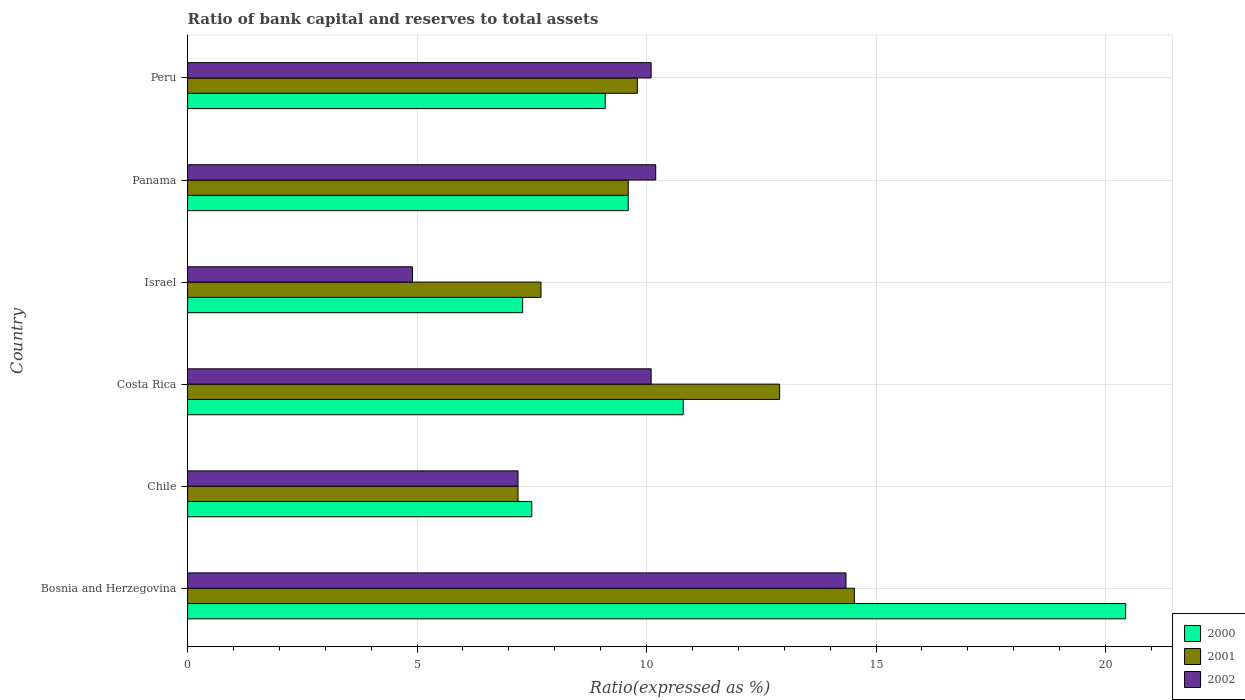How many different coloured bars are there?
Ensure brevity in your answer.  3. Are the number of bars per tick equal to the number of legend labels?
Make the answer very short. Yes. How many bars are there on the 6th tick from the top?
Offer a terse response. 3. What is the label of the 4th group of bars from the top?
Offer a terse response. Costa Rica. In how many cases, is the number of bars for a given country not equal to the number of legend labels?
Keep it short and to the point. 0. What is the ratio of bank capital and reserves to total assets in 2000 in Costa Rica?
Your response must be concise. 10.8. Across all countries, what is the maximum ratio of bank capital and reserves to total assets in 2001?
Offer a terse response. 14.53. Across all countries, what is the minimum ratio of bank capital and reserves to total assets in 2001?
Provide a succinct answer. 7.2. In which country was the ratio of bank capital and reserves to total assets in 2001 maximum?
Offer a very short reply. Bosnia and Herzegovina. What is the total ratio of bank capital and reserves to total assets in 2001 in the graph?
Your answer should be compact. 61.73. What is the difference between the ratio of bank capital and reserves to total assets in 2001 in Panama and that in Peru?
Provide a short and direct response. -0.2. What is the difference between the ratio of bank capital and reserves to total assets in 2001 in Panama and the ratio of bank capital and reserves to total assets in 2000 in Costa Rica?
Your answer should be compact. -1.2. What is the average ratio of bank capital and reserves to total assets in 2000 per country?
Give a very brief answer. 10.79. What is the difference between the ratio of bank capital and reserves to total assets in 2000 and ratio of bank capital and reserves to total assets in 2002 in Costa Rica?
Keep it short and to the point. 0.7. What is the ratio of the ratio of bank capital and reserves to total assets in 2000 in Israel to that in Panama?
Your response must be concise. 0.76. Is the difference between the ratio of bank capital and reserves to total assets in 2000 in Israel and Panama greater than the difference between the ratio of bank capital and reserves to total assets in 2002 in Israel and Panama?
Give a very brief answer. Yes. What is the difference between the highest and the second highest ratio of bank capital and reserves to total assets in 2001?
Your response must be concise. 1.63. What is the difference between the highest and the lowest ratio of bank capital and reserves to total assets in 2001?
Provide a succinct answer. 7.33. In how many countries, is the ratio of bank capital and reserves to total assets in 2001 greater than the average ratio of bank capital and reserves to total assets in 2001 taken over all countries?
Offer a terse response. 2. What does the 2nd bar from the top in Israel represents?
Offer a very short reply. 2001. How many countries are there in the graph?
Your response must be concise. 6. Are the values on the major ticks of X-axis written in scientific E-notation?
Your response must be concise. No. Does the graph contain any zero values?
Your answer should be compact. No. Does the graph contain grids?
Offer a very short reply. Yes. How many legend labels are there?
Provide a short and direct response. 3. How are the legend labels stacked?
Offer a very short reply. Vertical. What is the title of the graph?
Ensure brevity in your answer.  Ratio of bank capital and reserves to total assets. Does "1988" appear as one of the legend labels in the graph?
Make the answer very short. No. What is the label or title of the X-axis?
Your answer should be compact. Ratio(expressed as %). What is the Ratio(expressed as %) in 2000 in Bosnia and Herzegovina?
Offer a terse response. 20.44. What is the Ratio(expressed as %) in 2001 in Bosnia and Herzegovina?
Provide a succinct answer. 14.53. What is the Ratio(expressed as %) of 2002 in Bosnia and Herzegovina?
Offer a very short reply. 14.35. What is the Ratio(expressed as %) in 2001 in Costa Rica?
Your response must be concise. 12.9. What is the Ratio(expressed as %) of 2002 in Costa Rica?
Offer a terse response. 10.1. What is the Ratio(expressed as %) of 2002 in Panama?
Ensure brevity in your answer.  10.2. What is the Ratio(expressed as %) in 2001 in Peru?
Make the answer very short. 9.8. What is the Ratio(expressed as %) in 2002 in Peru?
Offer a very short reply. 10.1. Across all countries, what is the maximum Ratio(expressed as %) in 2000?
Give a very brief answer. 20.44. Across all countries, what is the maximum Ratio(expressed as %) of 2001?
Your answer should be compact. 14.53. Across all countries, what is the maximum Ratio(expressed as %) of 2002?
Provide a short and direct response. 14.35. Across all countries, what is the minimum Ratio(expressed as %) in 2002?
Offer a terse response. 4.9. What is the total Ratio(expressed as %) in 2000 in the graph?
Your answer should be very brief. 64.74. What is the total Ratio(expressed as %) in 2001 in the graph?
Your answer should be very brief. 61.73. What is the total Ratio(expressed as %) in 2002 in the graph?
Your answer should be compact. 56.85. What is the difference between the Ratio(expressed as %) of 2000 in Bosnia and Herzegovina and that in Chile?
Your answer should be very brief. 12.94. What is the difference between the Ratio(expressed as %) in 2001 in Bosnia and Herzegovina and that in Chile?
Ensure brevity in your answer.  7.33. What is the difference between the Ratio(expressed as %) of 2002 in Bosnia and Herzegovina and that in Chile?
Ensure brevity in your answer.  7.15. What is the difference between the Ratio(expressed as %) of 2000 in Bosnia and Herzegovina and that in Costa Rica?
Offer a terse response. 9.64. What is the difference between the Ratio(expressed as %) in 2001 in Bosnia and Herzegovina and that in Costa Rica?
Provide a short and direct response. 1.63. What is the difference between the Ratio(expressed as %) in 2002 in Bosnia and Herzegovina and that in Costa Rica?
Provide a short and direct response. 4.25. What is the difference between the Ratio(expressed as %) in 2000 in Bosnia and Herzegovina and that in Israel?
Keep it short and to the point. 13.14. What is the difference between the Ratio(expressed as %) in 2001 in Bosnia and Herzegovina and that in Israel?
Offer a terse response. 6.83. What is the difference between the Ratio(expressed as %) of 2002 in Bosnia and Herzegovina and that in Israel?
Offer a terse response. 9.45. What is the difference between the Ratio(expressed as %) in 2000 in Bosnia and Herzegovina and that in Panama?
Offer a terse response. 10.84. What is the difference between the Ratio(expressed as %) of 2001 in Bosnia and Herzegovina and that in Panama?
Offer a terse response. 4.93. What is the difference between the Ratio(expressed as %) of 2002 in Bosnia and Herzegovina and that in Panama?
Provide a short and direct response. 4.15. What is the difference between the Ratio(expressed as %) of 2000 in Bosnia and Herzegovina and that in Peru?
Your answer should be very brief. 11.34. What is the difference between the Ratio(expressed as %) in 2001 in Bosnia and Herzegovina and that in Peru?
Offer a terse response. 4.73. What is the difference between the Ratio(expressed as %) of 2002 in Bosnia and Herzegovina and that in Peru?
Keep it short and to the point. 4.25. What is the difference between the Ratio(expressed as %) of 2002 in Chile and that in Costa Rica?
Keep it short and to the point. -2.9. What is the difference between the Ratio(expressed as %) of 2000 in Chile and that in Israel?
Give a very brief answer. 0.2. What is the difference between the Ratio(expressed as %) in 2001 in Chile and that in Israel?
Ensure brevity in your answer.  -0.5. What is the difference between the Ratio(expressed as %) of 2002 in Chile and that in Israel?
Your response must be concise. 2.3. What is the difference between the Ratio(expressed as %) in 2000 in Chile and that in Panama?
Your answer should be very brief. -2.1. What is the difference between the Ratio(expressed as %) in 2001 in Chile and that in Panama?
Ensure brevity in your answer.  -2.4. What is the difference between the Ratio(expressed as %) of 2002 in Chile and that in Panama?
Ensure brevity in your answer.  -3. What is the difference between the Ratio(expressed as %) of 2000 in Chile and that in Peru?
Provide a short and direct response. -1.6. What is the difference between the Ratio(expressed as %) in 2001 in Chile and that in Peru?
Keep it short and to the point. -2.6. What is the difference between the Ratio(expressed as %) of 2002 in Costa Rica and that in Israel?
Provide a short and direct response. 5.2. What is the difference between the Ratio(expressed as %) in 2000 in Costa Rica and that in Panama?
Your answer should be very brief. 1.2. What is the difference between the Ratio(expressed as %) of 2001 in Costa Rica and that in Panama?
Provide a succinct answer. 3.3. What is the difference between the Ratio(expressed as %) in 2000 in Costa Rica and that in Peru?
Ensure brevity in your answer.  1.7. What is the difference between the Ratio(expressed as %) of 2002 in Costa Rica and that in Peru?
Provide a succinct answer. 0. What is the difference between the Ratio(expressed as %) in 2000 in Israel and that in Panama?
Give a very brief answer. -2.3. What is the difference between the Ratio(expressed as %) of 2001 in Israel and that in Peru?
Provide a short and direct response. -2.1. What is the difference between the Ratio(expressed as %) in 2002 in Panama and that in Peru?
Keep it short and to the point. 0.1. What is the difference between the Ratio(expressed as %) in 2000 in Bosnia and Herzegovina and the Ratio(expressed as %) in 2001 in Chile?
Make the answer very short. 13.24. What is the difference between the Ratio(expressed as %) in 2000 in Bosnia and Herzegovina and the Ratio(expressed as %) in 2002 in Chile?
Your answer should be compact. 13.24. What is the difference between the Ratio(expressed as %) of 2001 in Bosnia and Herzegovina and the Ratio(expressed as %) of 2002 in Chile?
Your answer should be compact. 7.33. What is the difference between the Ratio(expressed as %) of 2000 in Bosnia and Herzegovina and the Ratio(expressed as %) of 2001 in Costa Rica?
Give a very brief answer. 7.54. What is the difference between the Ratio(expressed as %) in 2000 in Bosnia and Herzegovina and the Ratio(expressed as %) in 2002 in Costa Rica?
Offer a very short reply. 10.34. What is the difference between the Ratio(expressed as %) in 2001 in Bosnia and Herzegovina and the Ratio(expressed as %) in 2002 in Costa Rica?
Your answer should be very brief. 4.43. What is the difference between the Ratio(expressed as %) in 2000 in Bosnia and Herzegovina and the Ratio(expressed as %) in 2001 in Israel?
Your answer should be compact. 12.74. What is the difference between the Ratio(expressed as %) in 2000 in Bosnia and Herzegovina and the Ratio(expressed as %) in 2002 in Israel?
Ensure brevity in your answer.  15.54. What is the difference between the Ratio(expressed as %) in 2001 in Bosnia and Herzegovina and the Ratio(expressed as %) in 2002 in Israel?
Provide a short and direct response. 9.63. What is the difference between the Ratio(expressed as %) of 2000 in Bosnia and Herzegovina and the Ratio(expressed as %) of 2001 in Panama?
Your response must be concise. 10.84. What is the difference between the Ratio(expressed as %) of 2000 in Bosnia and Herzegovina and the Ratio(expressed as %) of 2002 in Panama?
Your answer should be very brief. 10.24. What is the difference between the Ratio(expressed as %) of 2001 in Bosnia and Herzegovina and the Ratio(expressed as %) of 2002 in Panama?
Offer a terse response. 4.33. What is the difference between the Ratio(expressed as %) of 2000 in Bosnia and Herzegovina and the Ratio(expressed as %) of 2001 in Peru?
Make the answer very short. 10.64. What is the difference between the Ratio(expressed as %) of 2000 in Bosnia and Herzegovina and the Ratio(expressed as %) of 2002 in Peru?
Provide a succinct answer. 10.34. What is the difference between the Ratio(expressed as %) in 2001 in Bosnia and Herzegovina and the Ratio(expressed as %) in 2002 in Peru?
Provide a short and direct response. 4.43. What is the difference between the Ratio(expressed as %) in 2000 in Chile and the Ratio(expressed as %) in 2001 in Costa Rica?
Your response must be concise. -5.4. What is the difference between the Ratio(expressed as %) in 2000 in Chile and the Ratio(expressed as %) in 2002 in Costa Rica?
Your response must be concise. -2.6. What is the difference between the Ratio(expressed as %) of 2001 in Chile and the Ratio(expressed as %) of 2002 in Costa Rica?
Offer a terse response. -2.9. What is the difference between the Ratio(expressed as %) of 2000 in Chile and the Ratio(expressed as %) of 2002 in Israel?
Your response must be concise. 2.6. What is the difference between the Ratio(expressed as %) of 2001 in Chile and the Ratio(expressed as %) of 2002 in Israel?
Ensure brevity in your answer.  2.3. What is the difference between the Ratio(expressed as %) of 2000 in Chile and the Ratio(expressed as %) of 2002 in Panama?
Your answer should be very brief. -2.7. What is the difference between the Ratio(expressed as %) of 2000 in Chile and the Ratio(expressed as %) of 2002 in Peru?
Your answer should be very brief. -2.6. What is the difference between the Ratio(expressed as %) of 2001 in Chile and the Ratio(expressed as %) of 2002 in Peru?
Provide a succinct answer. -2.9. What is the difference between the Ratio(expressed as %) of 2000 in Costa Rica and the Ratio(expressed as %) of 2001 in Israel?
Your response must be concise. 3.1. What is the difference between the Ratio(expressed as %) of 2001 in Costa Rica and the Ratio(expressed as %) of 2002 in Israel?
Give a very brief answer. 8. What is the difference between the Ratio(expressed as %) of 2000 in Costa Rica and the Ratio(expressed as %) of 2001 in Panama?
Provide a succinct answer. 1.2. What is the difference between the Ratio(expressed as %) in 2001 in Costa Rica and the Ratio(expressed as %) in 2002 in Panama?
Make the answer very short. 2.7. What is the difference between the Ratio(expressed as %) in 2000 in Israel and the Ratio(expressed as %) in 2002 in Panama?
Your answer should be very brief. -2.9. What is the difference between the Ratio(expressed as %) in 2000 in Israel and the Ratio(expressed as %) in 2002 in Peru?
Your answer should be very brief. -2.8. What is the average Ratio(expressed as %) in 2000 per country?
Provide a short and direct response. 10.79. What is the average Ratio(expressed as %) of 2001 per country?
Keep it short and to the point. 10.29. What is the average Ratio(expressed as %) of 2002 per country?
Ensure brevity in your answer.  9.47. What is the difference between the Ratio(expressed as %) in 2000 and Ratio(expressed as %) in 2001 in Bosnia and Herzegovina?
Your answer should be very brief. 5.91. What is the difference between the Ratio(expressed as %) in 2000 and Ratio(expressed as %) in 2002 in Bosnia and Herzegovina?
Your answer should be compact. 6.09. What is the difference between the Ratio(expressed as %) in 2001 and Ratio(expressed as %) in 2002 in Bosnia and Herzegovina?
Provide a succinct answer. 0.18. What is the difference between the Ratio(expressed as %) of 2001 and Ratio(expressed as %) of 2002 in Chile?
Keep it short and to the point. 0. What is the difference between the Ratio(expressed as %) of 2000 and Ratio(expressed as %) of 2001 in Costa Rica?
Keep it short and to the point. -2.1. What is the difference between the Ratio(expressed as %) of 2000 and Ratio(expressed as %) of 2001 in Israel?
Give a very brief answer. -0.4. What is the difference between the Ratio(expressed as %) of 2000 and Ratio(expressed as %) of 2002 in Israel?
Give a very brief answer. 2.4. What is the difference between the Ratio(expressed as %) in 2001 and Ratio(expressed as %) in 2002 in Israel?
Your answer should be compact. 2.8. What is the difference between the Ratio(expressed as %) of 2000 and Ratio(expressed as %) of 2002 in Peru?
Your answer should be very brief. -1. What is the difference between the Ratio(expressed as %) in 2001 and Ratio(expressed as %) in 2002 in Peru?
Offer a very short reply. -0.3. What is the ratio of the Ratio(expressed as %) in 2000 in Bosnia and Herzegovina to that in Chile?
Keep it short and to the point. 2.73. What is the ratio of the Ratio(expressed as %) of 2001 in Bosnia and Herzegovina to that in Chile?
Give a very brief answer. 2.02. What is the ratio of the Ratio(expressed as %) of 2002 in Bosnia and Herzegovina to that in Chile?
Provide a short and direct response. 1.99. What is the ratio of the Ratio(expressed as %) in 2000 in Bosnia and Herzegovina to that in Costa Rica?
Offer a very short reply. 1.89. What is the ratio of the Ratio(expressed as %) in 2001 in Bosnia and Herzegovina to that in Costa Rica?
Offer a very short reply. 1.13. What is the ratio of the Ratio(expressed as %) of 2002 in Bosnia and Herzegovina to that in Costa Rica?
Offer a very short reply. 1.42. What is the ratio of the Ratio(expressed as %) of 2000 in Bosnia and Herzegovina to that in Israel?
Your response must be concise. 2.8. What is the ratio of the Ratio(expressed as %) in 2001 in Bosnia and Herzegovina to that in Israel?
Keep it short and to the point. 1.89. What is the ratio of the Ratio(expressed as %) in 2002 in Bosnia and Herzegovina to that in Israel?
Give a very brief answer. 2.93. What is the ratio of the Ratio(expressed as %) in 2000 in Bosnia and Herzegovina to that in Panama?
Your answer should be very brief. 2.13. What is the ratio of the Ratio(expressed as %) in 2001 in Bosnia and Herzegovina to that in Panama?
Your response must be concise. 1.51. What is the ratio of the Ratio(expressed as %) in 2002 in Bosnia and Herzegovina to that in Panama?
Your answer should be very brief. 1.41. What is the ratio of the Ratio(expressed as %) of 2000 in Bosnia and Herzegovina to that in Peru?
Give a very brief answer. 2.25. What is the ratio of the Ratio(expressed as %) of 2001 in Bosnia and Herzegovina to that in Peru?
Give a very brief answer. 1.48. What is the ratio of the Ratio(expressed as %) of 2002 in Bosnia and Herzegovina to that in Peru?
Give a very brief answer. 1.42. What is the ratio of the Ratio(expressed as %) in 2000 in Chile to that in Costa Rica?
Provide a succinct answer. 0.69. What is the ratio of the Ratio(expressed as %) of 2001 in Chile to that in Costa Rica?
Make the answer very short. 0.56. What is the ratio of the Ratio(expressed as %) in 2002 in Chile to that in Costa Rica?
Your response must be concise. 0.71. What is the ratio of the Ratio(expressed as %) of 2000 in Chile to that in Israel?
Ensure brevity in your answer.  1.03. What is the ratio of the Ratio(expressed as %) in 2001 in Chile to that in Israel?
Make the answer very short. 0.94. What is the ratio of the Ratio(expressed as %) of 2002 in Chile to that in Israel?
Provide a succinct answer. 1.47. What is the ratio of the Ratio(expressed as %) in 2000 in Chile to that in Panama?
Make the answer very short. 0.78. What is the ratio of the Ratio(expressed as %) of 2001 in Chile to that in Panama?
Your response must be concise. 0.75. What is the ratio of the Ratio(expressed as %) of 2002 in Chile to that in Panama?
Keep it short and to the point. 0.71. What is the ratio of the Ratio(expressed as %) in 2000 in Chile to that in Peru?
Your answer should be very brief. 0.82. What is the ratio of the Ratio(expressed as %) in 2001 in Chile to that in Peru?
Offer a very short reply. 0.73. What is the ratio of the Ratio(expressed as %) of 2002 in Chile to that in Peru?
Provide a short and direct response. 0.71. What is the ratio of the Ratio(expressed as %) of 2000 in Costa Rica to that in Israel?
Your answer should be compact. 1.48. What is the ratio of the Ratio(expressed as %) in 2001 in Costa Rica to that in Israel?
Provide a succinct answer. 1.68. What is the ratio of the Ratio(expressed as %) of 2002 in Costa Rica to that in Israel?
Keep it short and to the point. 2.06. What is the ratio of the Ratio(expressed as %) of 2001 in Costa Rica to that in Panama?
Your answer should be compact. 1.34. What is the ratio of the Ratio(expressed as %) of 2002 in Costa Rica to that in Panama?
Keep it short and to the point. 0.99. What is the ratio of the Ratio(expressed as %) in 2000 in Costa Rica to that in Peru?
Provide a short and direct response. 1.19. What is the ratio of the Ratio(expressed as %) of 2001 in Costa Rica to that in Peru?
Make the answer very short. 1.32. What is the ratio of the Ratio(expressed as %) in 2000 in Israel to that in Panama?
Ensure brevity in your answer.  0.76. What is the ratio of the Ratio(expressed as %) of 2001 in Israel to that in Panama?
Provide a succinct answer. 0.8. What is the ratio of the Ratio(expressed as %) of 2002 in Israel to that in Panama?
Offer a very short reply. 0.48. What is the ratio of the Ratio(expressed as %) in 2000 in Israel to that in Peru?
Give a very brief answer. 0.8. What is the ratio of the Ratio(expressed as %) in 2001 in Israel to that in Peru?
Your answer should be compact. 0.79. What is the ratio of the Ratio(expressed as %) in 2002 in Israel to that in Peru?
Your answer should be very brief. 0.49. What is the ratio of the Ratio(expressed as %) in 2000 in Panama to that in Peru?
Offer a terse response. 1.05. What is the ratio of the Ratio(expressed as %) of 2001 in Panama to that in Peru?
Give a very brief answer. 0.98. What is the ratio of the Ratio(expressed as %) in 2002 in Panama to that in Peru?
Your response must be concise. 1.01. What is the difference between the highest and the second highest Ratio(expressed as %) in 2000?
Ensure brevity in your answer.  9.64. What is the difference between the highest and the second highest Ratio(expressed as %) in 2001?
Give a very brief answer. 1.63. What is the difference between the highest and the second highest Ratio(expressed as %) of 2002?
Your response must be concise. 4.15. What is the difference between the highest and the lowest Ratio(expressed as %) of 2000?
Your answer should be compact. 13.14. What is the difference between the highest and the lowest Ratio(expressed as %) of 2001?
Your response must be concise. 7.33. What is the difference between the highest and the lowest Ratio(expressed as %) in 2002?
Give a very brief answer. 9.45. 